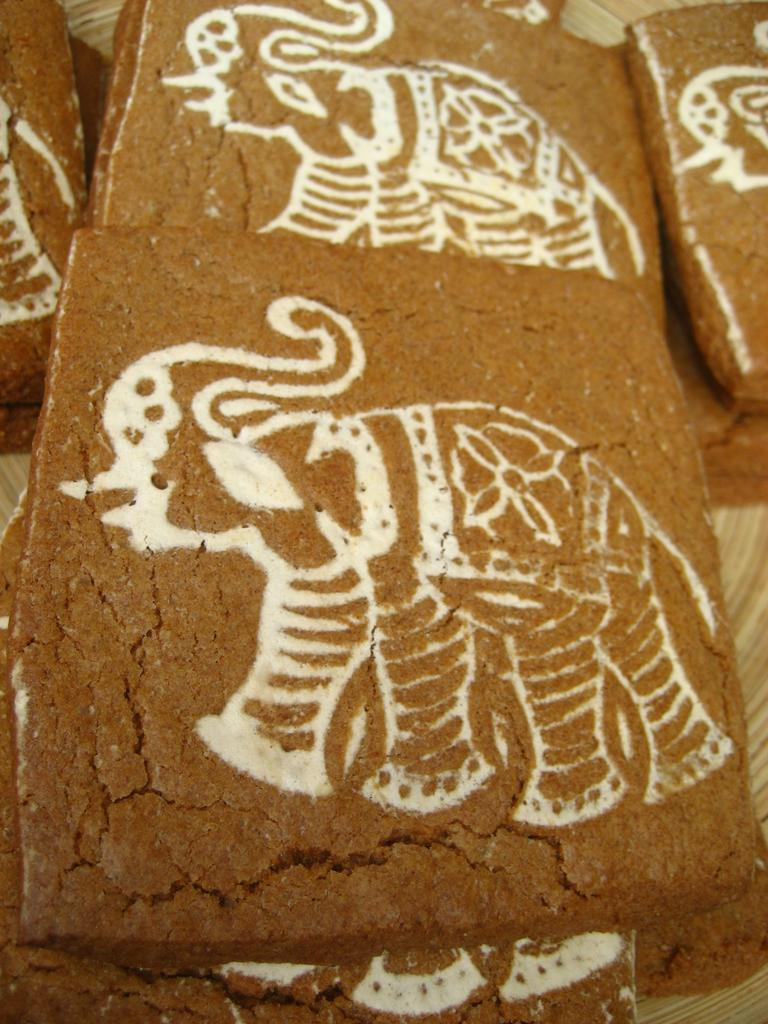What is the color of the objects in the image? The objects in the image are brown-colored. What is drawn or sketched on the brown-colored objects? There are sketches in white color on the brown-colored objects. Are there any cobwebs visible on the brown-colored objects in the image? There is no mention of cobwebs in the provided facts, so we cannot determine if any are present in the image. 